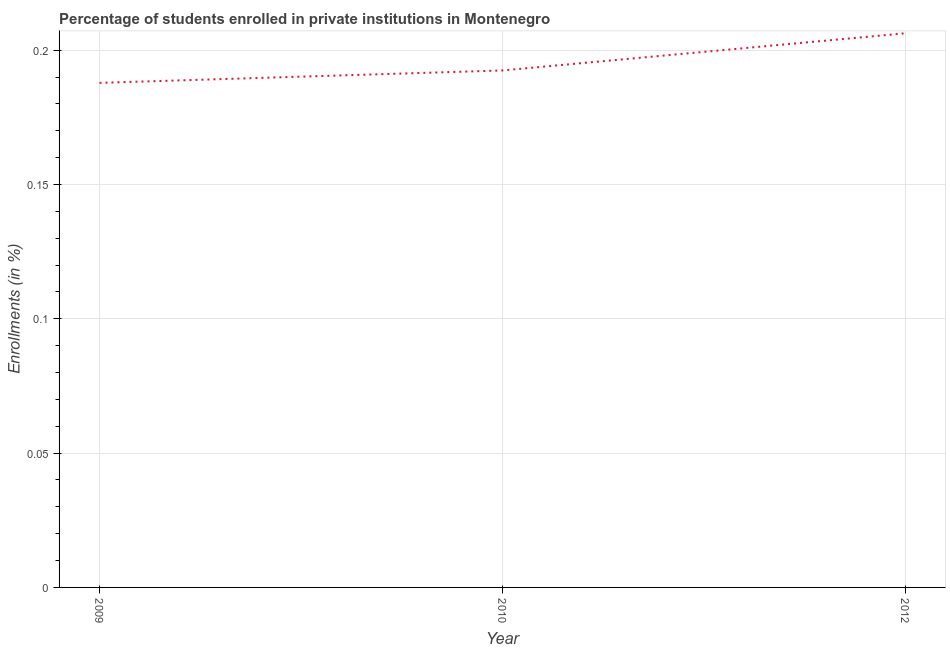What is the enrollments in private institutions in 2010?
Give a very brief answer. 0.19. Across all years, what is the maximum enrollments in private institutions?
Keep it short and to the point. 0.21. Across all years, what is the minimum enrollments in private institutions?
Your response must be concise. 0.19. In which year was the enrollments in private institutions minimum?
Your answer should be very brief. 2009. What is the sum of the enrollments in private institutions?
Offer a terse response. 0.59. What is the difference between the enrollments in private institutions in 2010 and 2012?
Make the answer very short. -0.01. What is the average enrollments in private institutions per year?
Provide a short and direct response. 0.2. What is the median enrollments in private institutions?
Give a very brief answer. 0.19. What is the ratio of the enrollments in private institutions in 2010 to that in 2012?
Keep it short and to the point. 0.93. Is the enrollments in private institutions in 2010 less than that in 2012?
Your answer should be compact. Yes. Is the difference between the enrollments in private institutions in 2010 and 2012 greater than the difference between any two years?
Keep it short and to the point. No. What is the difference between the highest and the second highest enrollments in private institutions?
Your answer should be very brief. 0.01. What is the difference between the highest and the lowest enrollments in private institutions?
Your answer should be compact. 0.02. Does the enrollments in private institutions monotonically increase over the years?
Offer a very short reply. Yes. How many lines are there?
Your answer should be compact. 1. How many years are there in the graph?
Make the answer very short. 3. Are the values on the major ticks of Y-axis written in scientific E-notation?
Ensure brevity in your answer.  No. Does the graph contain grids?
Your response must be concise. Yes. What is the title of the graph?
Provide a succinct answer. Percentage of students enrolled in private institutions in Montenegro. What is the label or title of the Y-axis?
Offer a very short reply. Enrollments (in %). What is the Enrollments (in %) in 2009?
Provide a short and direct response. 0.19. What is the Enrollments (in %) of 2010?
Ensure brevity in your answer.  0.19. What is the Enrollments (in %) of 2012?
Make the answer very short. 0.21. What is the difference between the Enrollments (in %) in 2009 and 2010?
Provide a succinct answer. -0. What is the difference between the Enrollments (in %) in 2009 and 2012?
Provide a short and direct response. -0.02. What is the difference between the Enrollments (in %) in 2010 and 2012?
Give a very brief answer. -0.01. What is the ratio of the Enrollments (in %) in 2009 to that in 2010?
Your response must be concise. 0.98. What is the ratio of the Enrollments (in %) in 2009 to that in 2012?
Your answer should be very brief. 0.91. What is the ratio of the Enrollments (in %) in 2010 to that in 2012?
Provide a short and direct response. 0.93. 